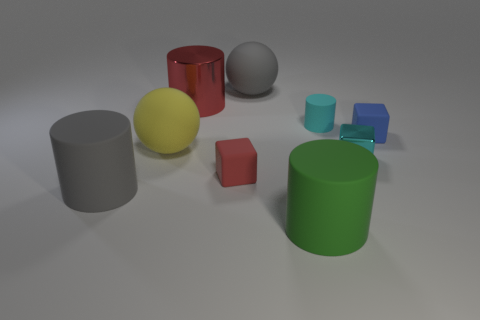Add 1 purple cubes. How many objects exist? 10 Subtract all cubes. How many objects are left? 6 Subtract all large red things. Subtract all big gray matte objects. How many objects are left? 6 Add 2 small blue blocks. How many small blue blocks are left? 3 Add 6 blue things. How many blue things exist? 7 Subtract 0 brown balls. How many objects are left? 9 